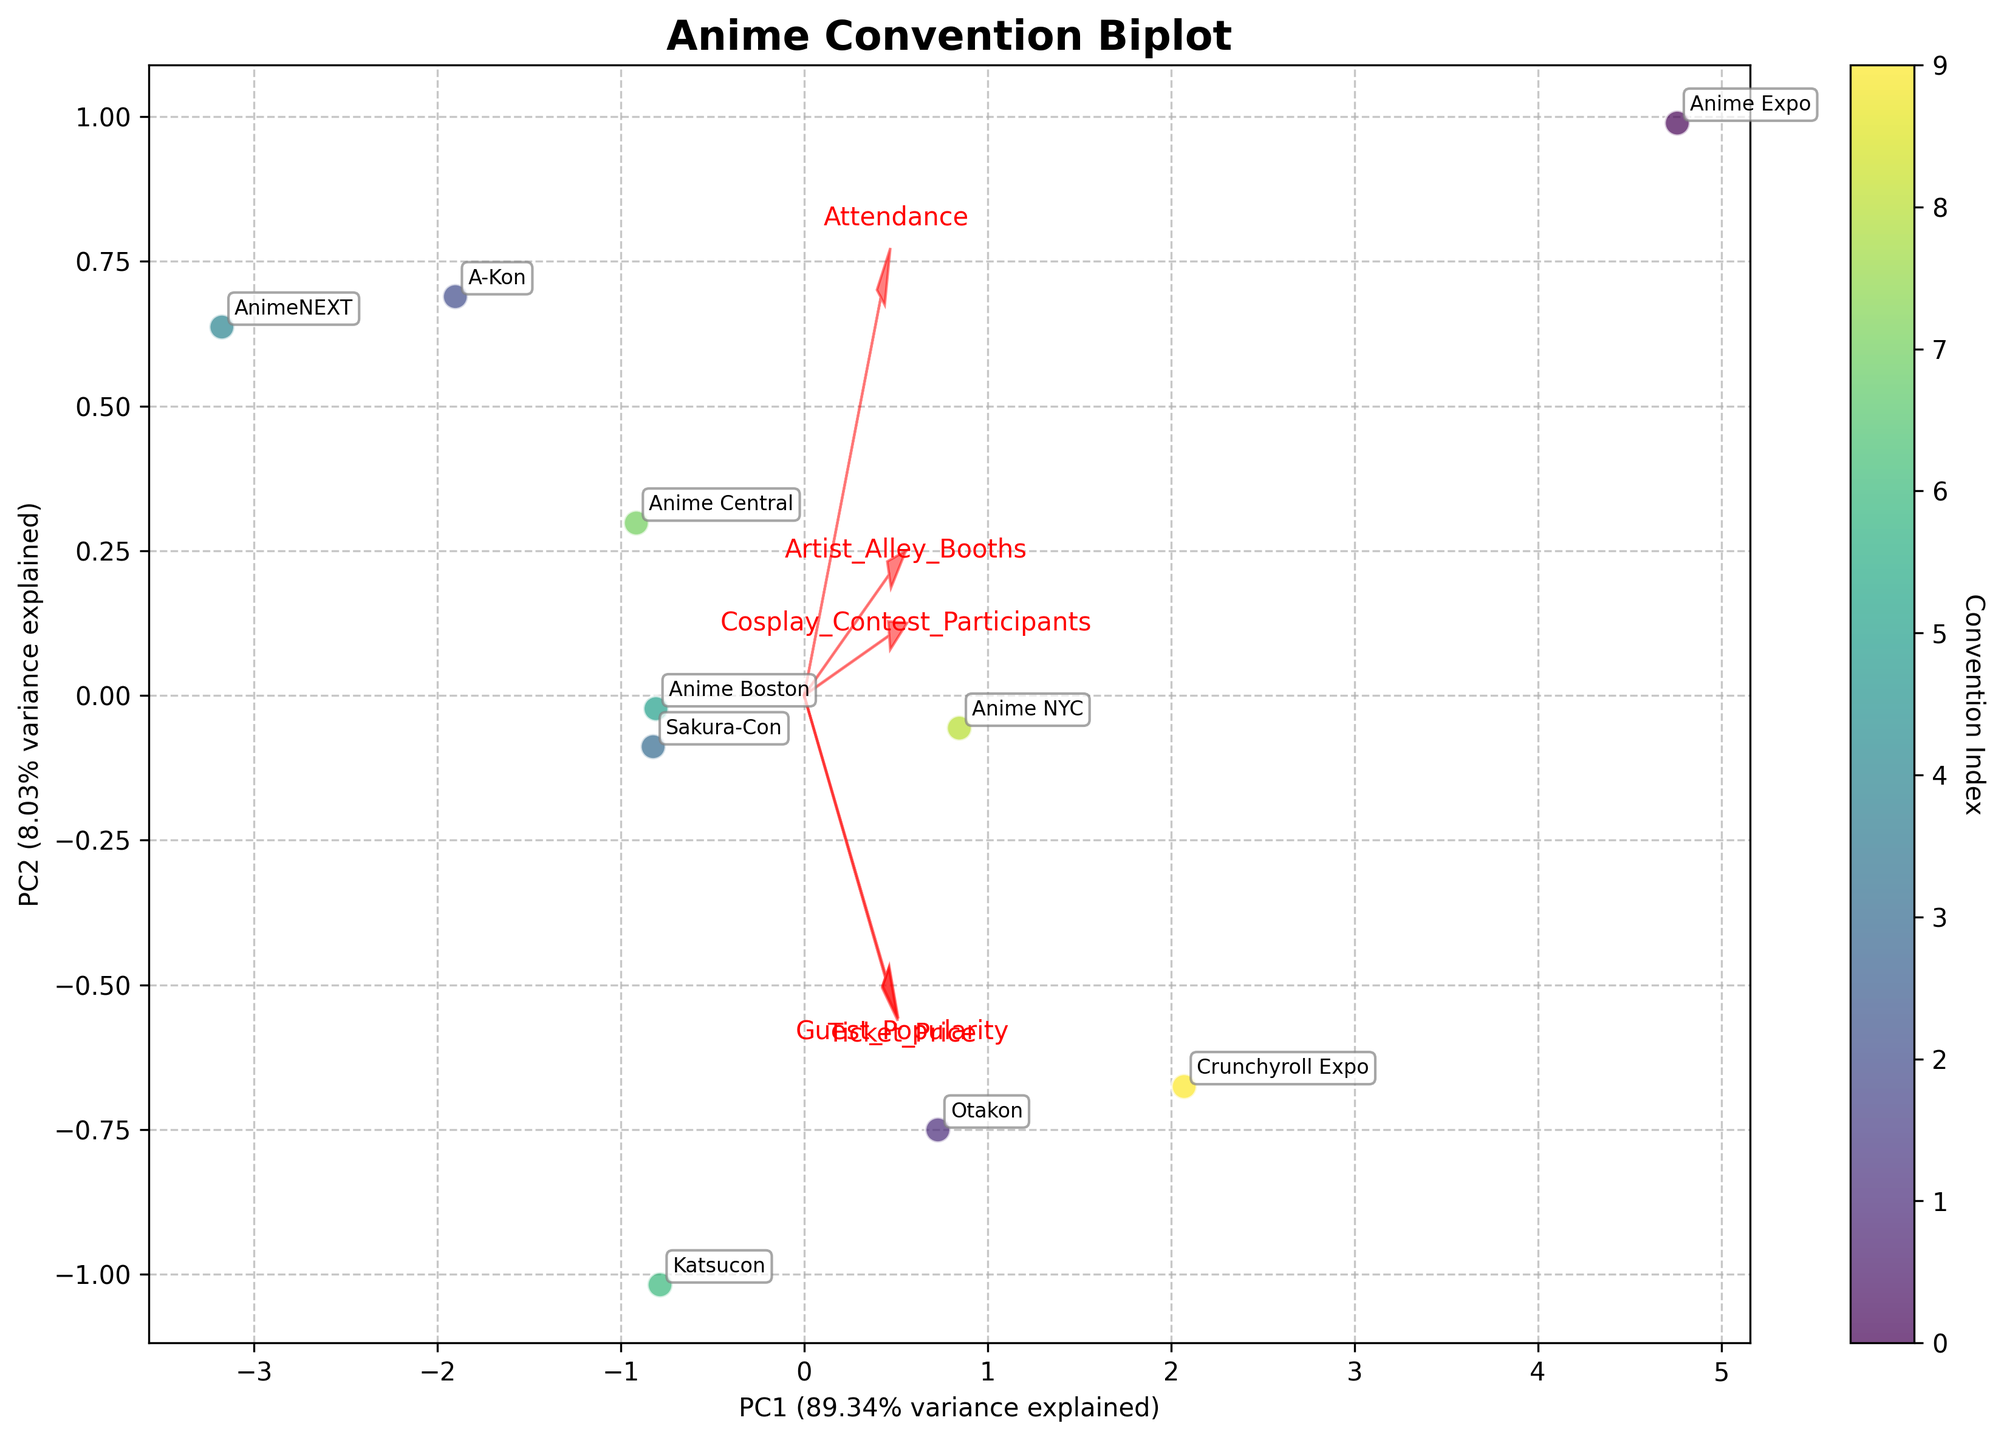What is the title of the plot? The title of the plot is found at the top of the figure and is clearly labeled. In this case, the title is prominently displayed as "Anime Convention Biplot".
Answer: Anime Convention Biplot How many conventions are represented in the plot? To determine the number of conventions, count each unique data point label annotated in the plot. The dataset provided lists 10 conventions, and each should correspond to a point in the biplot.
Answer: 10 Which convention has the highest attendance? Locate the point that represents the highest value in the 'Attendance' axis direction. The 'Attendance' vector points towards the convention with the highest value. According to the dataset, Anime Expo has the highest attendance.
Answer: Anime Expo Which feature has the strongest influence in the direction of the first principal component (PC1)? Identify the feature vector that is the largest along the PC1 axis. PC1 has the most variance explained, and the vector with the greatest length in the PC1 direction indicates the feature with the largest influence.
Answer: Attendance Which convention is closest to the origin of the biplot? The convention closest to the origin (where PC1 and PC2 are zero) can be identified by looking for the data point nearest to the center of the plot.
Answer: A-Kon or Sakura-Con (if they overlap) Which conventions have similar engagement metrics based on their proximity in the biplot? Conventions that are plotted close to each other in the biplot have similar engagement metrics because they have similar values in the context of the principal components. For example, Anime Central and A-Kon appear close together.
Answer: Anime Central and A-Kon Which convention has a balance of high ticket price and medium attendance as indicated by the vectors’ directions? Locate the convention close to the direction that is a balance between the 'Ticket_Price' and 'Attendance' vectors. A convention neither too high nor too low in either component suggests a medium balance.
Answer: Crunchyroll Expo How much of the variance is explained by the first two principal components? Look at the axis labels for PC1 and PC2. The percentages of variance explained by each are included in these labels. Summing these two percentages gives the total variance explained by the first two components. For instance, if PC1 explains 60% and PC2 explains 20%, total variance is 80%.
Answer: Sum of PC1 and PC2 variance explained Are cosplay contest participants more correlated with attendance or ticket price? Determine which principal component vector (Attendance or Ticket_Price) has a direction more aligned with the Cosplay_Contest_Participants vector. The closer the angle between the two vectors, the higher the correlation.
Answer: Attendance 